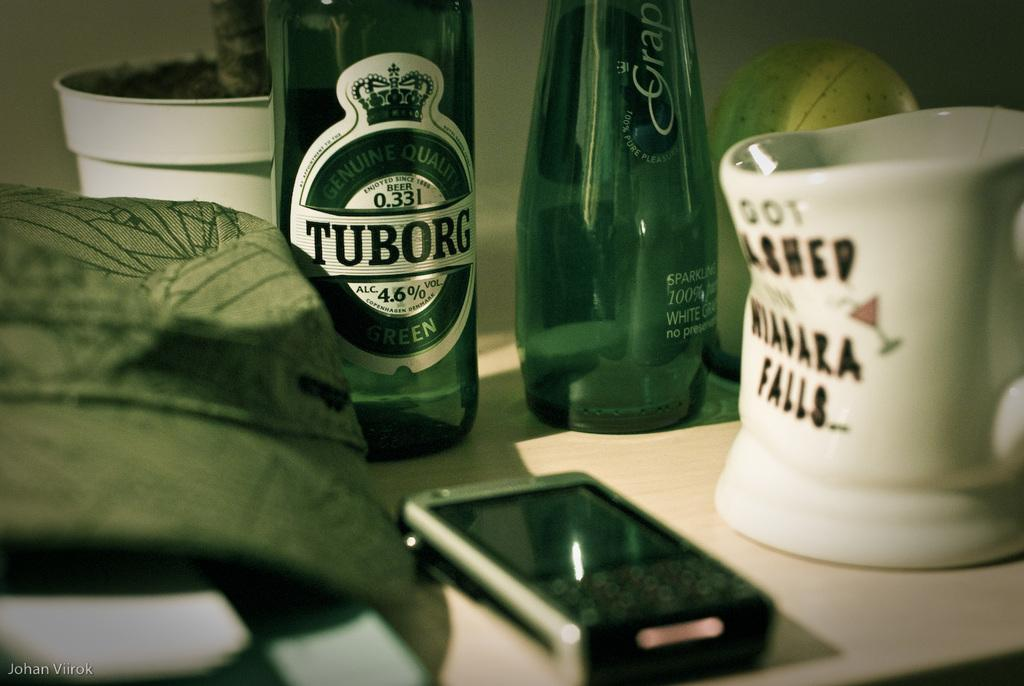Provide a one-sentence caption for the provided image. A glass of Tuborg and a mug on a desk. 